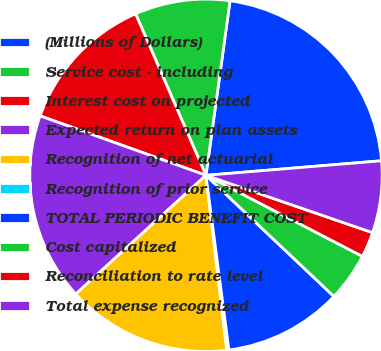Convert chart. <chart><loc_0><loc_0><loc_500><loc_500><pie_chart><fcel>(Millions of Dollars)<fcel>Service cost - including<fcel>Interest cost on projected<fcel>Expected return on plan assets<fcel>Recognition of net actuarial<fcel>Recognition of prior service<fcel>TOTAL PERIODIC BENEFIT COST<fcel>Cost capitalized<fcel>Reconciliation to rate level<fcel>Total expense recognized<nl><fcel>21.5%<fcel>8.72%<fcel>12.98%<fcel>17.24%<fcel>15.11%<fcel>0.2%<fcel>10.85%<fcel>4.46%<fcel>2.33%<fcel>6.59%<nl></chart> 